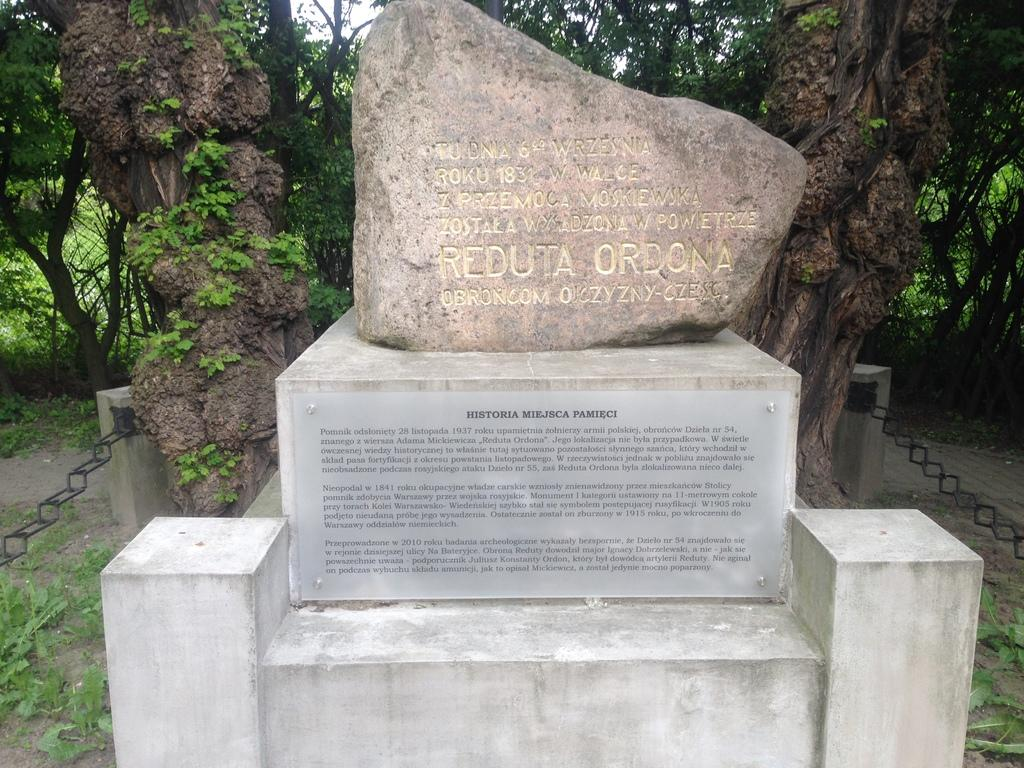What type of objects can be seen in the image? There are memorial stones in the image. What else is present in the image besides the memorial stones? There are plants and trees visible in the image. What can be seen beneath the memorial stones and plants? The ground is visible in the image. What type of bell can be heard ringing in the image? There is no bell present in the image, so it is not possible to hear it ringing. 